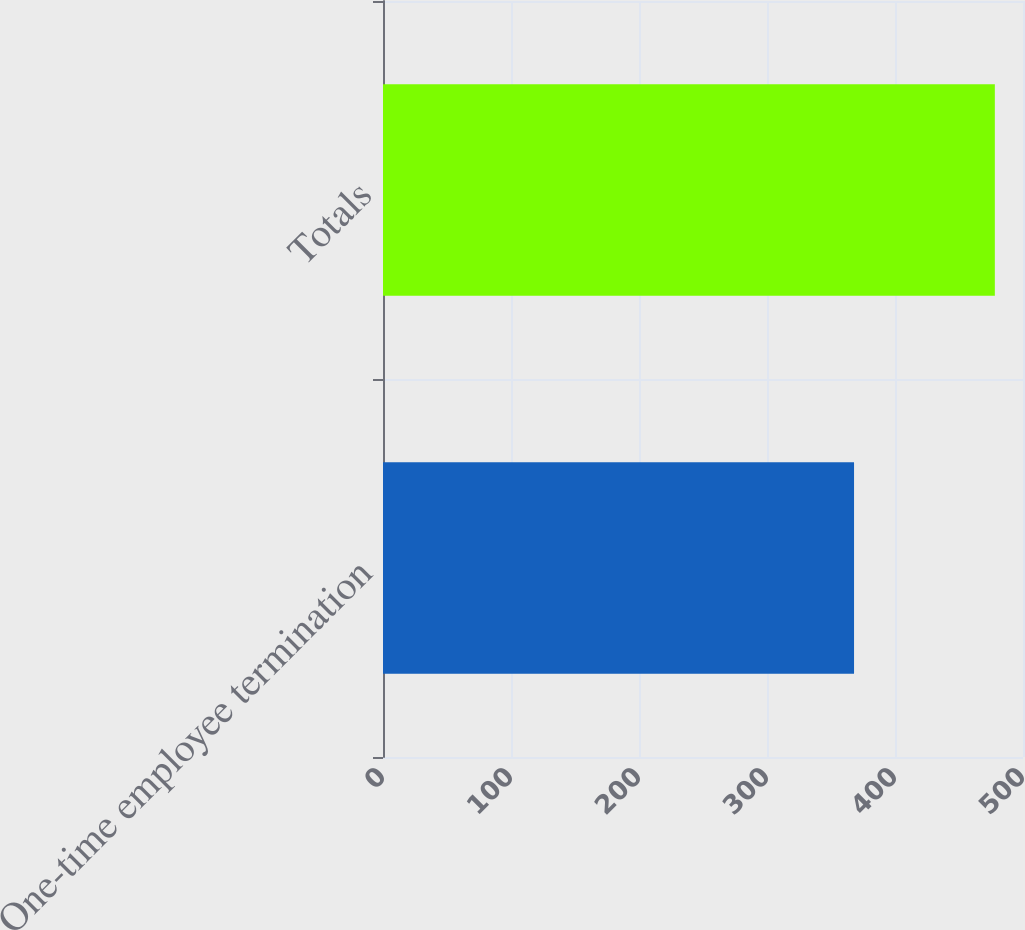<chart> <loc_0><loc_0><loc_500><loc_500><bar_chart><fcel>One-time employee termination<fcel>Totals<nl><fcel>368<fcel>478<nl></chart> 